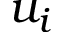<formula> <loc_0><loc_0><loc_500><loc_500>u _ { i }</formula> 